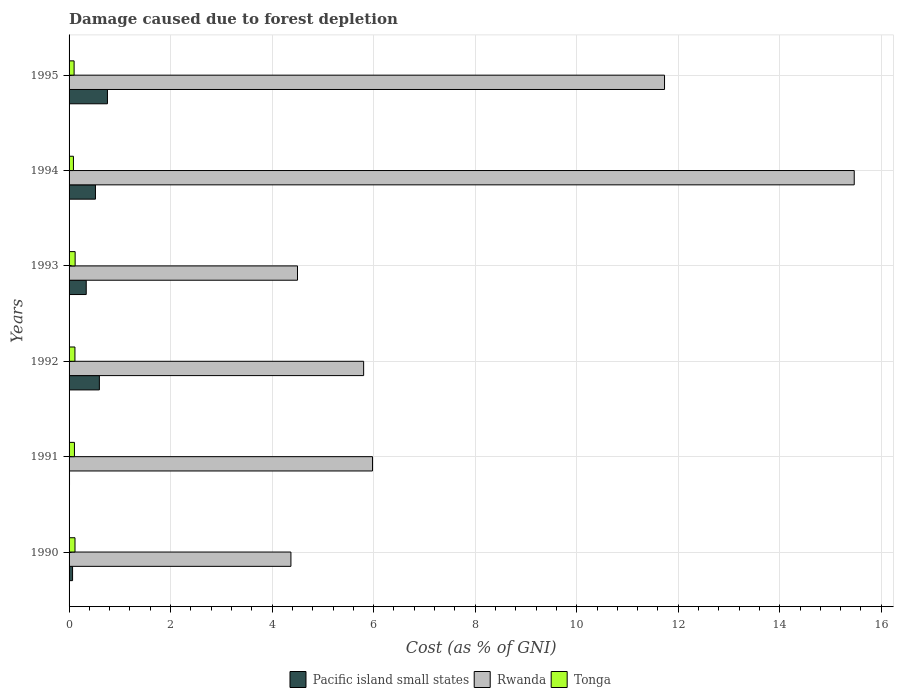How many different coloured bars are there?
Give a very brief answer. 3. Are the number of bars on each tick of the Y-axis equal?
Ensure brevity in your answer.  Yes. How many bars are there on the 4th tick from the top?
Your answer should be compact. 3. What is the label of the 4th group of bars from the top?
Provide a succinct answer. 1992. In how many cases, is the number of bars for a given year not equal to the number of legend labels?
Offer a terse response. 0. What is the cost of damage caused due to forest depletion in Pacific island small states in 1995?
Make the answer very short. 0.76. Across all years, what is the maximum cost of damage caused due to forest depletion in Tonga?
Your answer should be very brief. 0.12. Across all years, what is the minimum cost of damage caused due to forest depletion in Rwanda?
Keep it short and to the point. 4.37. In which year was the cost of damage caused due to forest depletion in Pacific island small states maximum?
Offer a terse response. 1995. What is the total cost of damage caused due to forest depletion in Rwanda in the graph?
Your answer should be compact. 47.85. What is the difference between the cost of damage caused due to forest depletion in Tonga in 1991 and that in 1992?
Offer a very short reply. -0.01. What is the difference between the cost of damage caused due to forest depletion in Rwanda in 1990 and the cost of damage caused due to forest depletion in Tonga in 1991?
Offer a terse response. 4.26. What is the average cost of damage caused due to forest depletion in Tonga per year?
Provide a short and direct response. 0.11. In the year 1992, what is the difference between the cost of damage caused due to forest depletion in Tonga and cost of damage caused due to forest depletion in Rwanda?
Provide a succinct answer. -5.69. In how many years, is the cost of damage caused due to forest depletion in Pacific island small states greater than 8.8 %?
Make the answer very short. 0. What is the ratio of the cost of damage caused due to forest depletion in Tonga in 1991 to that in 1994?
Make the answer very short. 1.23. Is the cost of damage caused due to forest depletion in Rwanda in 1993 less than that in 1995?
Offer a terse response. Yes. Is the difference between the cost of damage caused due to forest depletion in Tonga in 1990 and 1991 greater than the difference between the cost of damage caused due to forest depletion in Rwanda in 1990 and 1991?
Provide a short and direct response. Yes. What is the difference between the highest and the second highest cost of damage caused due to forest depletion in Rwanda?
Provide a succinct answer. 3.74. What is the difference between the highest and the lowest cost of damage caused due to forest depletion in Pacific island small states?
Your response must be concise. 0.75. In how many years, is the cost of damage caused due to forest depletion in Rwanda greater than the average cost of damage caused due to forest depletion in Rwanda taken over all years?
Keep it short and to the point. 2. What does the 2nd bar from the top in 1994 represents?
Make the answer very short. Rwanda. What does the 1st bar from the bottom in 1993 represents?
Keep it short and to the point. Pacific island small states. Is it the case that in every year, the sum of the cost of damage caused due to forest depletion in Tonga and cost of damage caused due to forest depletion in Pacific island small states is greater than the cost of damage caused due to forest depletion in Rwanda?
Offer a terse response. No. What is the difference between two consecutive major ticks on the X-axis?
Offer a terse response. 2. Does the graph contain any zero values?
Provide a succinct answer. No. How many legend labels are there?
Offer a terse response. 3. What is the title of the graph?
Ensure brevity in your answer.  Damage caused due to forest depletion. Does "Bolivia" appear as one of the legend labels in the graph?
Provide a succinct answer. No. What is the label or title of the X-axis?
Give a very brief answer. Cost (as % of GNI). What is the label or title of the Y-axis?
Keep it short and to the point. Years. What is the Cost (as % of GNI) in Pacific island small states in 1990?
Offer a terse response. 0.07. What is the Cost (as % of GNI) in Rwanda in 1990?
Your answer should be very brief. 4.37. What is the Cost (as % of GNI) of Tonga in 1990?
Your answer should be compact. 0.12. What is the Cost (as % of GNI) of Pacific island small states in 1991?
Give a very brief answer. 0.01. What is the Cost (as % of GNI) in Rwanda in 1991?
Make the answer very short. 5.98. What is the Cost (as % of GNI) of Tonga in 1991?
Provide a short and direct response. 0.11. What is the Cost (as % of GNI) of Pacific island small states in 1992?
Keep it short and to the point. 0.6. What is the Cost (as % of GNI) in Rwanda in 1992?
Your answer should be very brief. 5.8. What is the Cost (as % of GNI) of Tonga in 1992?
Provide a short and direct response. 0.12. What is the Cost (as % of GNI) in Pacific island small states in 1993?
Give a very brief answer. 0.34. What is the Cost (as % of GNI) of Rwanda in 1993?
Make the answer very short. 4.5. What is the Cost (as % of GNI) of Tonga in 1993?
Provide a short and direct response. 0.12. What is the Cost (as % of GNI) in Pacific island small states in 1994?
Your response must be concise. 0.52. What is the Cost (as % of GNI) of Rwanda in 1994?
Give a very brief answer. 15.47. What is the Cost (as % of GNI) of Tonga in 1994?
Give a very brief answer. 0.09. What is the Cost (as % of GNI) of Pacific island small states in 1995?
Ensure brevity in your answer.  0.76. What is the Cost (as % of GNI) in Rwanda in 1995?
Your response must be concise. 11.73. What is the Cost (as % of GNI) in Tonga in 1995?
Make the answer very short. 0.1. Across all years, what is the maximum Cost (as % of GNI) of Pacific island small states?
Your answer should be very brief. 0.76. Across all years, what is the maximum Cost (as % of GNI) in Rwanda?
Offer a terse response. 15.47. Across all years, what is the maximum Cost (as % of GNI) in Tonga?
Provide a short and direct response. 0.12. Across all years, what is the minimum Cost (as % of GNI) in Pacific island small states?
Your answer should be very brief. 0.01. Across all years, what is the minimum Cost (as % of GNI) in Rwanda?
Keep it short and to the point. 4.37. Across all years, what is the minimum Cost (as % of GNI) in Tonga?
Ensure brevity in your answer.  0.09. What is the total Cost (as % of GNI) of Pacific island small states in the graph?
Give a very brief answer. 2.29. What is the total Cost (as % of GNI) of Rwanda in the graph?
Your response must be concise. 47.85. What is the total Cost (as % of GNI) in Tonga in the graph?
Offer a terse response. 0.64. What is the difference between the Cost (as % of GNI) of Pacific island small states in 1990 and that in 1991?
Provide a short and direct response. 0.06. What is the difference between the Cost (as % of GNI) of Rwanda in 1990 and that in 1991?
Offer a very short reply. -1.61. What is the difference between the Cost (as % of GNI) of Tonga in 1990 and that in 1991?
Make the answer very short. 0.01. What is the difference between the Cost (as % of GNI) in Pacific island small states in 1990 and that in 1992?
Give a very brief answer. -0.53. What is the difference between the Cost (as % of GNI) in Rwanda in 1990 and that in 1992?
Keep it short and to the point. -1.43. What is the difference between the Cost (as % of GNI) in Tonga in 1990 and that in 1992?
Your answer should be compact. 0. What is the difference between the Cost (as % of GNI) of Pacific island small states in 1990 and that in 1993?
Offer a terse response. -0.27. What is the difference between the Cost (as % of GNI) in Rwanda in 1990 and that in 1993?
Offer a terse response. -0.13. What is the difference between the Cost (as % of GNI) of Tonga in 1990 and that in 1993?
Your response must be concise. -0. What is the difference between the Cost (as % of GNI) in Pacific island small states in 1990 and that in 1994?
Keep it short and to the point. -0.45. What is the difference between the Cost (as % of GNI) in Rwanda in 1990 and that in 1994?
Give a very brief answer. -11.1. What is the difference between the Cost (as % of GNI) of Tonga in 1990 and that in 1994?
Offer a very short reply. 0.03. What is the difference between the Cost (as % of GNI) of Pacific island small states in 1990 and that in 1995?
Ensure brevity in your answer.  -0.69. What is the difference between the Cost (as % of GNI) in Rwanda in 1990 and that in 1995?
Ensure brevity in your answer.  -7.36. What is the difference between the Cost (as % of GNI) of Tonga in 1990 and that in 1995?
Make the answer very short. 0.02. What is the difference between the Cost (as % of GNI) in Pacific island small states in 1991 and that in 1992?
Make the answer very short. -0.59. What is the difference between the Cost (as % of GNI) in Rwanda in 1991 and that in 1992?
Offer a very short reply. 0.17. What is the difference between the Cost (as % of GNI) in Tonga in 1991 and that in 1992?
Provide a succinct answer. -0.01. What is the difference between the Cost (as % of GNI) of Pacific island small states in 1991 and that in 1993?
Your answer should be compact. -0.33. What is the difference between the Cost (as % of GNI) of Rwanda in 1991 and that in 1993?
Make the answer very short. 1.48. What is the difference between the Cost (as % of GNI) of Tonga in 1991 and that in 1993?
Keep it short and to the point. -0.01. What is the difference between the Cost (as % of GNI) in Pacific island small states in 1991 and that in 1994?
Provide a succinct answer. -0.51. What is the difference between the Cost (as % of GNI) in Rwanda in 1991 and that in 1994?
Keep it short and to the point. -9.49. What is the difference between the Cost (as % of GNI) of Tonga in 1991 and that in 1994?
Make the answer very short. 0.02. What is the difference between the Cost (as % of GNI) of Pacific island small states in 1991 and that in 1995?
Provide a succinct answer. -0.75. What is the difference between the Cost (as % of GNI) of Rwanda in 1991 and that in 1995?
Offer a very short reply. -5.75. What is the difference between the Cost (as % of GNI) in Tonga in 1991 and that in 1995?
Make the answer very short. 0.01. What is the difference between the Cost (as % of GNI) in Pacific island small states in 1992 and that in 1993?
Your response must be concise. 0.26. What is the difference between the Cost (as % of GNI) of Rwanda in 1992 and that in 1993?
Offer a very short reply. 1.3. What is the difference between the Cost (as % of GNI) in Tonga in 1992 and that in 1993?
Your answer should be very brief. -0. What is the difference between the Cost (as % of GNI) in Pacific island small states in 1992 and that in 1994?
Provide a succinct answer. 0.08. What is the difference between the Cost (as % of GNI) in Rwanda in 1992 and that in 1994?
Ensure brevity in your answer.  -9.66. What is the difference between the Cost (as % of GNI) of Tonga in 1992 and that in 1994?
Offer a very short reply. 0.03. What is the difference between the Cost (as % of GNI) in Pacific island small states in 1992 and that in 1995?
Offer a terse response. -0.16. What is the difference between the Cost (as % of GNI) in Rwanda in 1992 and that in 1995?
Provide a succinct answer. -5.93. What is the difference between the Cost (as % of GNI) of Tonga in 1992 and that in 1995?
Ensure brevity in your answer.  0.02. What is the difference between the Cost (as % of GNI) in Pacific island small states in 1993 and that in 1994?
Give a very brief answer. -0.18. What is the difference between the Cost (as % of GNI) of Rwanda in 1993 and that in 1994?
Offer a terse response. -10.97. What is the difference between the Cost (as % of GNI) in Tonga in 1993 and that in 1994?
Make the answer very short. 0.03. What is the difference between the Cost (as % of GNI) of Pacific island small states in 1993 and that in 1995?
Offer a terse response. -0.42. What is the difference between the Cost (as % of GNI) in Rwanda in 1993 and that in 1995?
Make the answer very short. -7.23. What is the difference between the Cost (as % of GNI) of Tonga in 1993 and that in 1995?
Provide a short and direct response. 0.02. What is the difference between the Cost (as % of GNI) in Pacific island small states in 1994 and that in 1995?
Your answer should be compact. -0.24. What is the difference between the Cost (as % of GNI) of Rwanda in 1994 and that in 1995?
Keep it short and to the point. 3.74. What is the difference between the Cost (as % of GNI) in Tonga in 1994 and that in 1995?
Make the answer very short. -0.01. What is the difference between the Cost (as % of GNI) of Pacific island small states in 1990 and the Cost (as % of GNI) of Rwanda in 1991?
Keep it short and to the point. -5.91. What is the difference between the Cost (as % of GNI) in Pacific island small states in 1990 and the Cost (as % of GNI) in Tonga in 1991?
Give a very brief answer. -0.04. What is the difference between the Cost (as % of GNI) in Rwanda in 1990 and the Cost (as % of GNI) in Tonga in 1991?
Provide a succinct answer. 4.26. What is the difference between the Cost (as % of GNI) of Pacific island small states in 1990 and the Cost (as % of GNI) of Rwanda in 1992?
Your answer should be compact. -5.73. What is the difference between the Cost (as % of GNI) of Pacific island small states in 1990 and the Cost (as % of GNI) of Tonga in 1992?
Offer a very short reply. -0.05. What is the difference between the Cost (as % of GNI) of Rwanda in 1990 and the Cost (as % of GNI) of Tonga in 1992?
Your answer should be very brief. 4.25. What is the difference between the Cost (as % of GNI) in Pacific island small states in 1990 and the Cost (as % of GNI) in Rwanda in 1993?
Your answer should be compact. -4.43. What is the difference between the Cost (as % of GNI) of Pacific island small states in 1990 and the Cost (as % of GNI) of Tonga in 1993?
Give a very brief answer. -0.05. What is the difference between the Cost (as % of GNI) in Rwanda in 1990 and the Cost (as % of GNI) in Tonga in 1993?
Ensure brevity in your answer.  4.25. What is the difference between the Cost (as % of GNI) of Pacific island small states in 1990 and the Cost (as % of GNI) of Rwanda in 1994?
Ensure brevity in your answer.  -15.4. What is the difference between the Cost (as % of GNI) in Pacific island small states in 1990 and the Cost (as % of GNI) in Tonga in 1994?
Give a very brief answer. -0.02. What is the difference between the Cost (as % of GNI) in Rwanda in 1990 and the Cost (as % of GNI) in Tonga in 1994?
Your answer should be compact. 4.28. What is the difference between the Cost (as % of GNI) of Pacific island small states in 1990 and the Cost (as % of GNI) of Rwanda in 1995?
Provide a succinct answer. -11.66. What is the difference between the Cost (as % of GNI) of Pacific island small states in 1990 and the Cost (as % of GNI) of Tonga in 1995?
Give a very brief answer. -0.03. What is the difference between the Cost (as % of GNI) in Rwanda in 1990 and the Cost (as % of GNI) in Tonga in 1995?
Ensure brevity in your answer.  4.27. What is the difference between the Cost (as % of GNI) of Pacific island small states in 1991 and the Cost (as % of GNI) of Rwanda in 1992?
Offer a very short reply. -5.79. What is the difference between the Cost (as % of GNI) in Pacific island small states in 1991 and the Cost (as % of GNI) in Tonga in 1992?
Make the answer very short. -0.11. What is the difference between the Cost (as % of GNI) in Rwanda in 1991 and the Cost (as % of GNI) in Tonga in 1992?
Your response must be concise. 5.86. What is the difference between the Cost (as % of GNI) of Pacific island small states in 1991 and the Cost (as % of GNI) of Rwanda in 1993?
Provide a short and direct response. -4.49. What is the difference between the Cost (as % of GNI) in Pacific island small states in 1991 and the Cost (as % of GNI) in Tonga in 1993?
Offer a very short reply. -0.11. What is the difference between the Cost (as % of GNI) of Rwanda in 1991 and the Cost (as % of GNI) of Tonga in 1993?
Provide a short and direct response. 5.86. What is the difference between the Cost (as % of GNI) of Pacific island small states in 1991 and the Cost (as % of GNI) of Rwanda in 1994?
Provide a short and direct response. -15.46. What is the difference between the Cost (as % of GNI) in Pacific island small states in 1991 and the Cost (as % of GNI) in Tonga in 1994?
Your answer should be very brief. -0.08. What is the difference between the Cost (as % of GNI) of Rwanda in 1991 and the Cost (as % of GNI) of Tonga in 1994?
Your answer should be very brief. 5.89. What is the difference between the Cost (as % of GNI) of Pacific island small states in 1991 and the Cost (as % of GNI) of Rwanda in 1995?
Ensure brevity in your answer.  -11.72. What is the difference between the Cost (as % of GNI) in Pacific island small states in 1991 and the Cost (as % of GNI) in Tonga in 1995?
Your answer should be compact. -0.09. What is the difference between the Cost (as % of GNI) of Rwanda in 1991 and the Cost (as % of GNI) of Tonga in 1995?
Your response must be concise. 5.88. What is the difference between the Cost (as % of GNI) in Pacific island small states in 1992 and the Cost (as % of GNI) in Rwanda in 1993?
Your answer should be very brief. -3.9. What is the difference between the Cost (as % of GNI) of Pacific island small states in 1992 and the Cost (as % of GNI) of Tonga in 1993?
Make the answer very short. 0.48. What is the difference between the Cost (as % of GNI) of Rwanda in 1992 and the Cost (as % of GNI) of Tonga in 1993?
Provide a succinct answer. 5.68. What is the difference between the Cost (as % of GNI) in Pacific island small states in 1992 and the Cost (as % of GNI) in Rwanda in 1994?
Offer a very short reply. -14.87. What is the difference between the Cost (as % of GNI) in Pacific island small states in 1992 and the Cost (as % of GNI) in Tonga in 1994?
Your answer should be very brief. 0.51. What is the difference between the Cost (as % of GNI) of Rwanda in 1992 and the Cost (as % of GNI) of Tonga in 1994?
Keep it short and to the point. 5.72. What is the difference between the Cost (as % of GNI) in Pacific island small states in 1992 and the Cost (as % of GNI) in Rwanda in 1995?
Your response must be concise. -11.13. What is the difference between the Cost (as % of GNI) of Pacific island small states in 1992 and the Cost (as % of GNI) of Tonga in 1995?
Your answer should be very brief. 0.5. What is the difference between the Cost (as % of GNI) of Rwanda in 1992 and the Cost (as % of GNI) of Tonga in 1995?
Give a very brief answer. 5.7. What is the difference between the Cost (as % of GNI) of Pacific island small states in 1993 and the Cost (as % of GNI) of Rwanda in 1994?
Your response must be concise. -15.13. What is the difference between the Cost (as % of GNI) of Pacific island small states in 1993 and the Cost (as % of GNI) of Tonga in 1994?
Provide a short and direct response. 0.25. What is the difference between the Cost (as % of GNI) of Rwanda in 1993 and the Cost (as % of GNI) of Tonga in 1994?
Ensure brevity in your answer.  4.41. What is the difference between the Cost (as % of GNI) in Pacific island small states in 1993 and the Cost (as % of GNI) in Rwanda in 1995?
Your answer should be very brief. -11.39. What is the difference between the Cost (as % of GNI) in Pacific island small states in 1993 and the Cost (as % of GNI) in Tonga in 1995?
Your answer should be compact. 0.24. What is the difference between the Cost (as % of GNI) in Rwanda in 1993 and the Cost (as % of GNI) in Tonga in 1995?
Offer a very short reply. 4.4. What is the difference between the Cost (as % of GNI) in Pacific island small states in 1994 and the Cost (as % of GNI) in Rwanda in 1995?
Keep it short and to the point. -11.21. What is the difference between the Cost (as % of GNI) of Pacific island small states in 1994 and the Cost (as % of GNI) of Tonga in 1995?
Your answer should be very brief. 0.42. What is the difference between the Cost (as % of GNI) in Rwanda in 1994 and the Cost (as % of GNI) in Tonga in 1995?
Provide a short and direct response. 15.37. What is the average Cost (as % of GNI) in Pacific island small states per year?
Your response must be concise. 0.38. What is the average Cost (as % of GNI) of Rwanda per year?
Offer a terse response. 7.97. What is the average Cost (as % of GNI) of Tonga per year?
Ensure brevity in your answer.  0.11. In the year 1990, what is the difference between the Cost (as % of GNI) of Pacific island small states and Cost (as % of GNI) of Rwanda?
Offer a terse response. -4.3. In the year 1990, what is the difference between the Cost (as % of GNI) in Pacific island small states and Cost (as % of GNI) in Tonga?
Keep it short and to the point. -0.05. In the year 1990, what is the difference between the Cost (as % of GNI) in Rwanda and Cost (as % of GNI) in Tonga?
Make the answer very short. 4.25. In the year 1991, what is the difference between the Cost (as % of GNI) in Pacific island small states and Cost (as % of GNI) in Rwanda?
Your response must be concise. -5.97. In the year 1991, what is the difference between the Cost (as % of GNI) in Pacific island small states and Cost (as % of GNI) in Tonga?
Provide a succinct answer. -0.1. In the year 1991, what is the difference between the Cost (as % of GNI) of Rwanda and Cost (as % of GNI) of Tonga?
Give a very brief answer. 5.87. In the year 1992, what is the difference between the Cost (as % of GNI) of Pacific island small states and Cost (as % of GNI) of Rwanda?
Your answer should be compact. -5.21. In the year 1992, what is the difference between the Cost (as % of GNI) in Pacific island small states and Cost (as % of GNI) in Tonga?
Your answer should be very brief. 0.48. In the year 1992, what is the difference between the Cost (as % of GNI) in Rwanda and Cost (as % of GNI) in Tonga?
Make the answer very short. 5.69. In the year 1993, what is the difference between the Cost (as % of GNI) of Pacific island small states and Cost (as % of GNI) of Rwanda?
Your answer should be compact. -4.16. In the year 1993, what is the difference between the Cost (as % of GNI) of Pacific island small states and Cost (as % of GNI) of Tonga?
Offer a terse response. 0.22. In the year 1993, what is the difference between the Cost (as % of GNI) of Rwanda and Cost (as % of GNI) of Tonga?
Your answer should be compact. 4.38. In the year 1994, what is the difference between the Cost (as % of GNI) of Pacific island small states and Cost (as % of GNI) of Rwanda?
Provide a short and direct response. -14.95. In the year 1994, what is the difference between the Cost (as % of GNI) of Pacific island small states and Cost (as % of GNI) of Tonga?
Your response must be concise. 0.43. In the year 1994, what is the difference between the Cost (as % of GNI) in Rwanda and Cost (as % of GNI) in Tonga?
Provide a short and direct response. 15.38. In the year 1995, what is the difference between the Cost (as % of GNI) in Pacific island small states and Cost (as % of GNI) in Rwanda?
Your response must be concise. -10.97. In the year 1995, what is the difference between the Cost (as % of GNI) of Pacific island small states and Cost (as % of GNI) of Tonga?
Keep it short and to the point. 0.66. In the year 1995, what is the difference between the Cost (as % of GNI) in Rwanda and Cost (as % of GNI) in Tonga?
Ensure brevity in your answer.  11.63. What is the ratio of the Cost (as % of GNI) of Pacific island small states in 1990 to that in 1991?
Your answer should be very brief. 7.97. What is the ratio of the Cost (as % of GNI) in Rwanda in 1990 to that in 1991?
Ensure brevity in your answer.  0.73. What is the ratio of the Cost (as % of GNI) of Tonga in 1990 to that in 1991?
Ensure brevity in your answer.  1.1. What is the ratio of the Cost (as % of GNI) of Pacific island small states in 1990 to that in 1992?
Keep it short and to the point. 0.12. What is the ratio of the Cost (as % of GNI) in Rwanda in 1990 to that in 1992?
Your answer should be very brief. 0.75. What is the ratio of the Cost (as % of GNI) of Tonga in 1990 to that in 1992?
Your answer should be compact. 1.01. What is the ratio of the Cost (as % of GNI) of Pacific island small states in 1990 to that in 1993?
Offer a very short reply. 0.2. What is the ratio of the Cost (as % of GNI) of Rwanda in 1990 to that in 1993?
Make the answer very short. 0.97. What is the ratio of the Cost (as % of GNI) of Tonga in 1990 to that in 1993?
Provide a short and direct response. 0.98. What is the ratio of the Cost (as % of GNI) of Pacific island small states in 1990 to that in 1994?
Make the answer very short. 0.13. What is the ratio of the Cost (as % of GNI) of Rwanda in 1990 to that in 1994?
Give a very brief answer. 0.28. What is the ratio of the Cost (as % of GNI) in Tonga in 1990 to that in 1994?
Keep it short and to the point. 1.36. What is the ratio of the Cost (as % of GNI) in Pacific island small states in 1990 to that in 1995?
Provide a succinct answer. 0.09. What is the ratio of the Cost (as % of GNI) of Rwanda in 1990 to that in 1995?
Your answer should be very brief. 0.37. What is the ratio of the Cost (as % of GNI) of Tonga in 1990 to that in 1995?
Offer a terse response. 1.18. What is the ratio of the Cost (as % of GNI) in Pacific island small states in 1991 to that in 1992?
Ensure brevity in your answer.  0.01. What is the ratio of the Cost (as % of GNI) of Rwanda in 1991 to that in 1992?
Your response must be concise. 1.03. What is the ratio of the Cost (as % of GNI) in Tonga in 1991 to that in 1992?
Offer a terse response. 0.92. What is the ratio of the Cost (as % of GNI) in Pacific island small states in 1991 to that in 1993?
Offer a very short reply. 0.03. What is the ratio of the Cost (as % of GNI) in Rwanda in 1991 to that in 1993?
Provide a short and direct response. 1.33. What is the ratio of the Cost (as % of GNI) in Tonga in 1991 to that in 1993?
Make the answer very short. 0.89. What is the ratio of the Cost (as % of GNI) in Pacific island small states in 1991 to that in 1994?
Keep it short and to the point. 0.02. What is the ratio of the Cost (as % of GNI) in Rwanda in 1991 to that in 1994?
Your response must be concise. 0.39. What is the ratio of the Cost (as % of GNI) in Tonga in 1991 to that in 1994?
Provide a short and direct response. 1.23. What is the ratio of the Cost (as % of GNI) in Pacific island small states in 1991 to that in 1995?
Offer a terse response. 0.01. What is the ratio of the Cost (as % of GNI) of Rwanda in 1991 to that in 1995?
Your response must be concise. 0.51. What is the ratio of the Cost (as % of GNI) in Tonga in 1991 to that in 1995?
Give a very brief answer. 1.07. What is the ratio of the Cost (as % of GNI) of Pacific island small states in 1992 to that in 1993?
Your answer should be very brief. 1.77. What is the ratio of the Cost (as % of GNI) of Rwanda in 1992 to that in 1993?
Provide a succinct answer. 1.29. What is the ratio of the Cost (as % of GNI) of Tonga in 1992 to that in 1993?
Provide a short and direct response. 0.97. What is the ratio of the Cost (as % of GNI) of Pacific island small states in 1992 to that in 1994?
Give a very brief answer. 1.15. What is the ratio of the Cost (as % of GNI) in Rwanda in 1992 to that in 1994?
Your answer should be very brief. 0.38. What is the ratio of the Cost (as % of GNI) of Tonga in 1992 to that in 1994?
Provide a short and direct response. 1.34. What is the ratio of the Cost (as % of GNI) in Pacific island small states in 1992 to that in 1995?
Provide a short and direct response. 0.79. What is the ratio of the Cost (as % of GNI) in Rwanda in 1992 to that in 1995?
Provide a succinct answer. 0.49. What is the ratio of the Cost (as % of GNI) in Tonga in 1992 to that in 1995?
Ensure brevity in your answer.  1.17. What is the ratio of the Cost (as % of GNI) of Pacific island small states in 1993 to that in 1994?
Offer a very short reply. 0.65. What is the ratio of the Cost (as % of GNI) of Rwanda in 1993 to that in 1994?
Provide a succinct answer. 0.29. What is the ratio of the Cost (as % of GNI) of Tonga in 1993 to that in 1994?
Your answer should be very brief. 1.39. What is the ratio of the Cost (as % of GNI) in Pacific island small states in 1993 to that in 1995?
Offer a very short reply. 0.45. What is the ratio of the Cost (as % of GNI) of Rwanda in 1993 to that in 1995?
Offer a terse response. 0.38. What is the ratio of the Cost (as % of GNI) in Tonga in 1993 to that in 1995?
Keep it short and to the point. 1.21. What is the ratio of the Cost (as % of GNI) of Pacific island small states in 1994 to that in 1995?
Give a very brief answer. 0.69. What is the ratio of the Cost (as % of GNI) in Rwanda in 1994 to that in 1995?
Ensure brevity in your answer.  1.32. What is the ratio of the Cost (as % of GNI) in Tonga in 1994 to that in 1995?
Ensure brevity in your answer.  0.87. What is the difference between the highest and the second highest Cost (as % of GNI) in Pacific island small states?
Offer a terse response. 0.16. What is the difference between the highest and the second highest Cost (as % of GNI) in Rwanda?
Offer a terse response. 3.74. What is the difference between the highest and the second highest Cost (as % of GNI) of Tonga?
Ensure brevity in your answer.  0. What is the difference between the highest and the lowest Cost (as % of GNI) of Pacific island small states?
Provide a short and direct response. 0.75. What is the difference between the highest and the lowest Cost (as % of GNI) of Rwanda?
Ensure brevity in your answer.  11.1. 